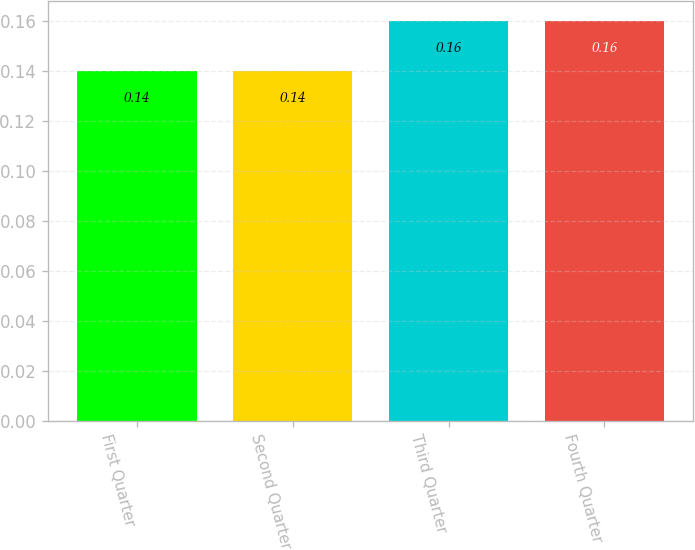Convert chart to OTSL. <chart><loc_0><loc_0><loc_500><loc_500><bar_chart><fcel>First Quarter<fcel>Second Quarter<fcel>Third Quarter<fcel>Fourth Quarter<nl><fcel>0.14<fcel>0.14<fcel>0.16<fcel>0.16<nl></chart> 